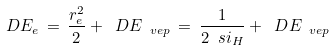<formula> <loc_0><loc_0><loc_500><loc_500>\ D E _ { e } \, = \, \frac { r _ { e } ^ { 2 } } { 2 } + \ D E _ { \ v e p } \, = \, \frac { 1 } { 2 \ s i _ { H } } + \ D E _ { \ v e p }</formula> 